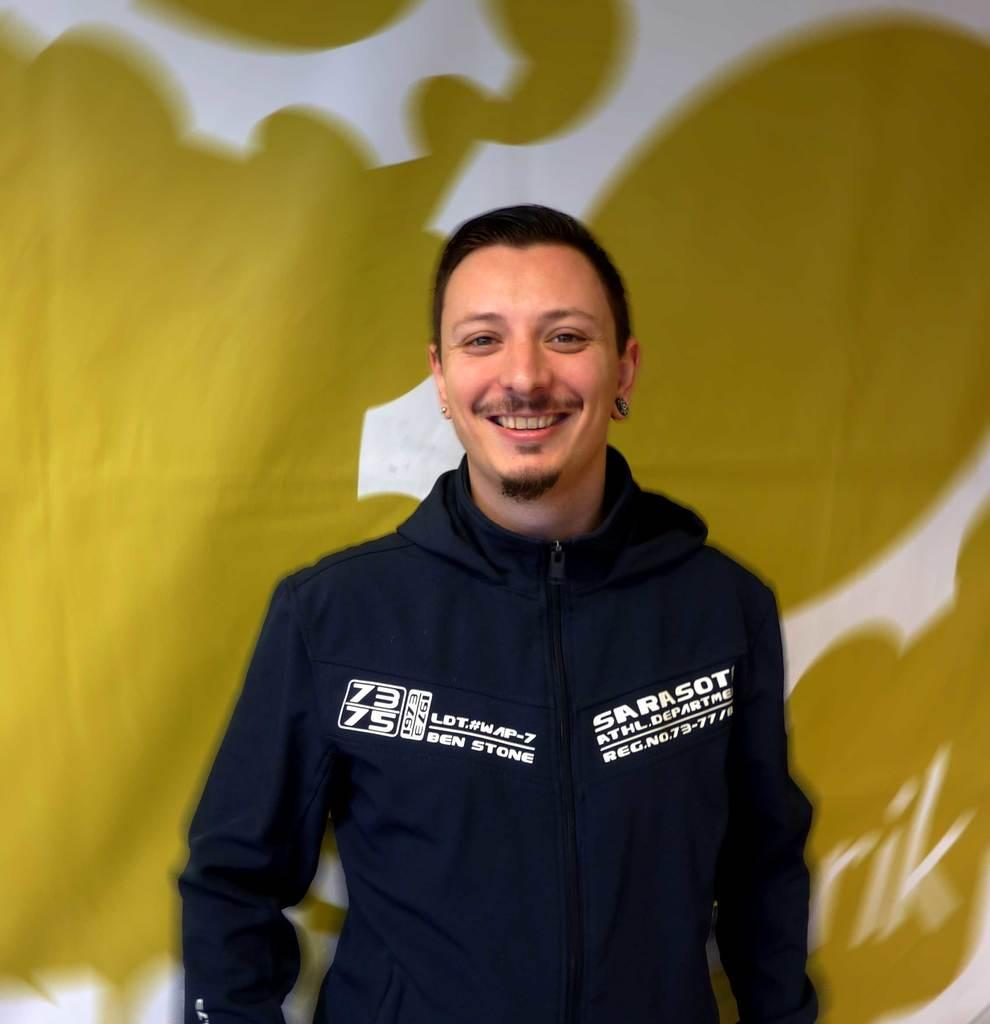<image>
Relay a brief, clear account of the picture shown. A smiling man has the number 73 and 75 on his sweatshirt. 